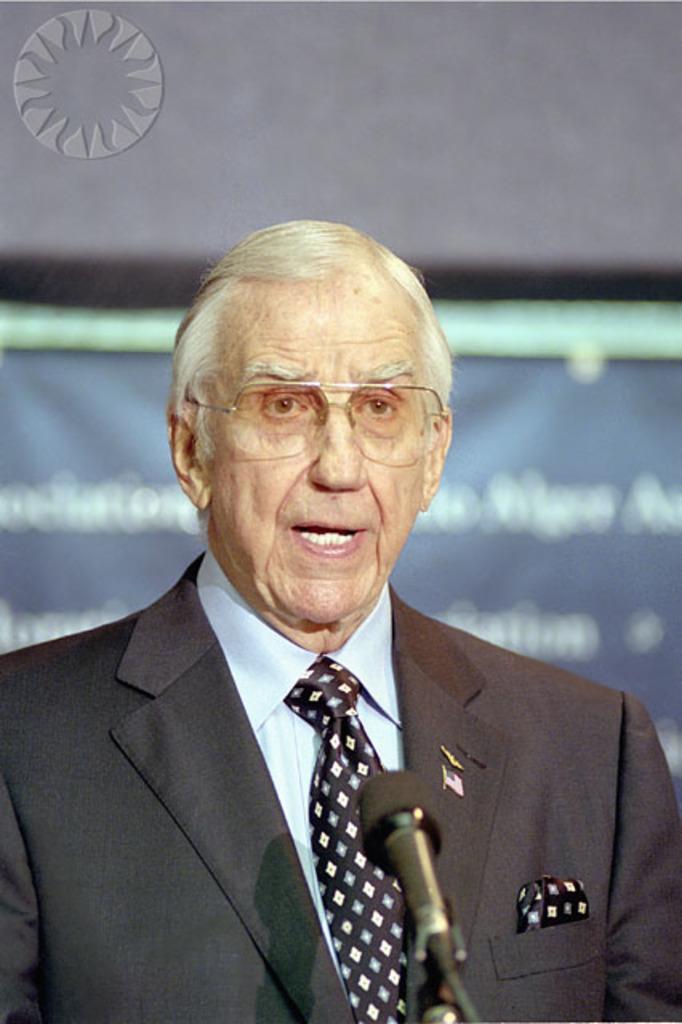Describe this image in one or two sentences. In this picture I can see there is a person standing and he is wearing a blazer, spectacles and he is speaking, there is a microphone in front of him and there is a banner in the backdrop and there is something written on it. There is a logo at the left side top corner of the image. 